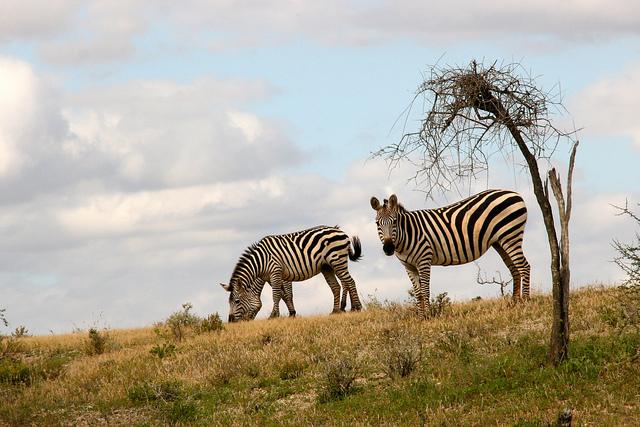How many animals are there?
Give a very brief answer. 2. Are the zebras in the wild or a zoo?
Concise answer only. Wild. How many trees are there?
Concise answer only. 1. Is the grass more green?
Short answer required. No. 